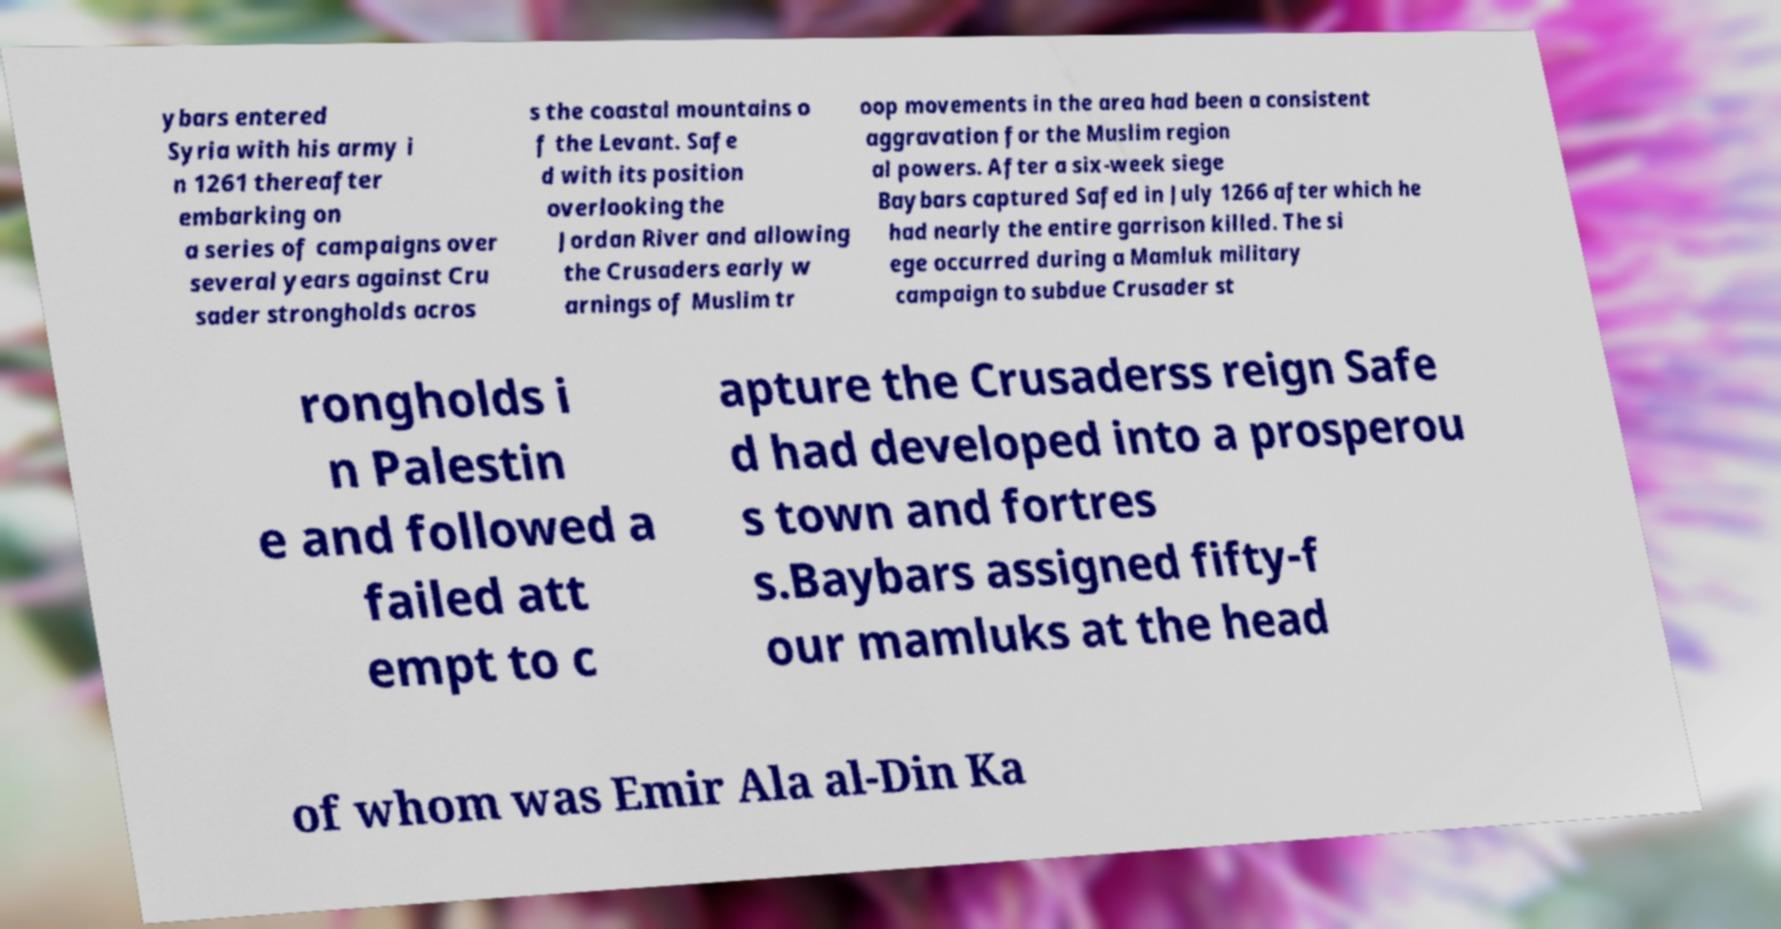What messages or text are displayed in this image? I need them in a readable, typed format. ybars entered Syria with his army i n 1261 thereafter embarking on a series of campaigns over several years against Cru sader strongholds acros s the coastal mountains o f the Levant. Safe d with its position overlooking the Jordan River and allowing the Crusaders early w arnings of Muslim tr oop movements in the area had been a consistent aggravation for the Muslim region al powers. After a six-week siege Baybars captured Safed in July 1266 after which he had nearly the entire garrison killed. The si ege occurred during a Mamluk military campaign to subdue Crusader st rongholds i n Palestin e and followed a failed att empt to c apture the Crusaderss reign Safe d had developed into a prosperou s town and fortres s.Baybars assigned fifty-f our mamluks at the head of whom was Emir Ala al-Din Ka 